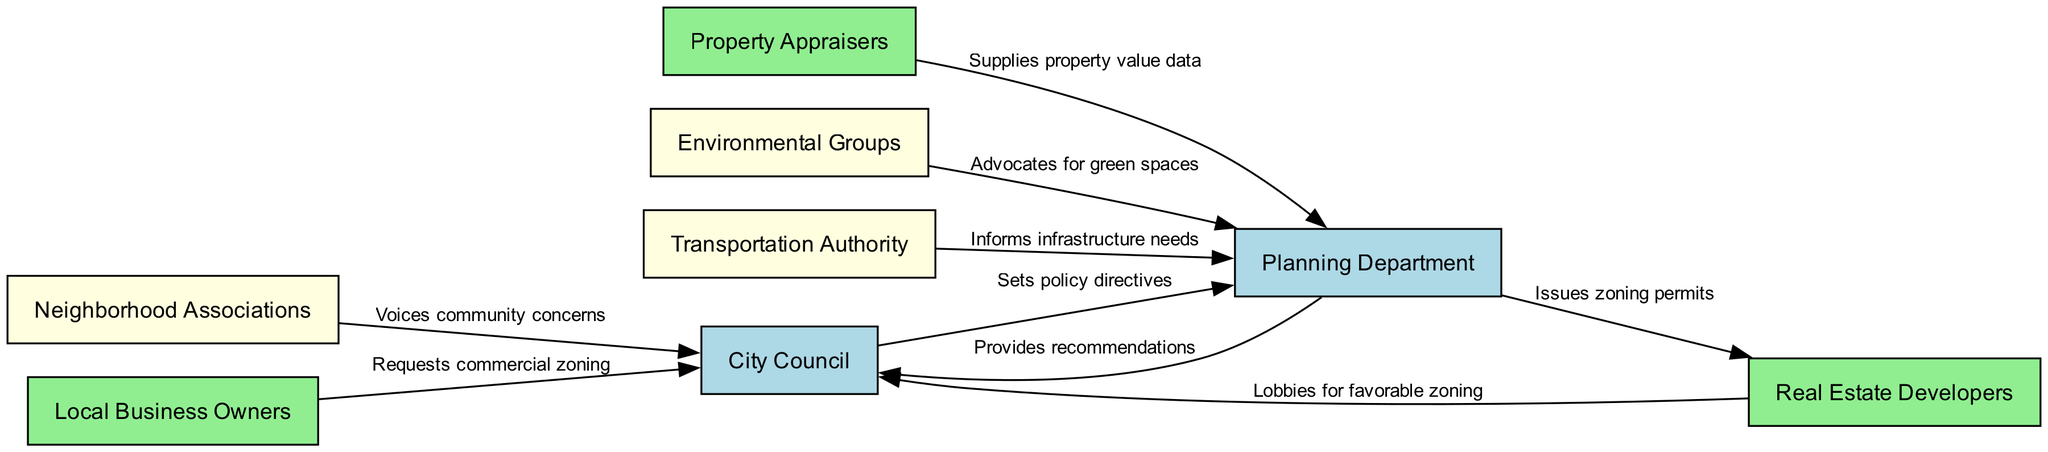What is the total number of nodes in the diagram? The diagram contains a list of entities involved in urban planning decisions, which are represented as nodes. Counting these, we have eight distinct nodes.
Answer: 8 Which entity voices community concerns? By examining the relationships in the diagram, the arrow leading to the City Council labeled "Voices community concerns" indicates that the Neighborhood Associations express community issues.
Answer: Neighborhood Associations What type of relationship does the Planning Department have with Real Estate Developers? The edge between the Planning Department and Real Estate Developers is labeled "Issues zoning permits," indicating a direct relationship where the Planning Department has the responsibility to grant zoning permits to them.
Answer: Issues zoning permits Who provides recommendations to the City Council? The diagram shows a directed edge from the Planning Department to the City Council with the label "Provides recommendations," indicating that the Planning Department is responsible for offering these recommendations.
Answer: Planning Department What is the role of Environmental Groups in the urban planning process? Environmental Groups have a connection to the Planning Department with the edge labeled "Advocates for green spaces," representing their role as advocates for environmental considerations in urban planning.
Answer: Advocates for green spaces Which group lobbies for favorable zoning? The diagram indicates that the Real Estate Developers lobby for zoning changes, as represented by the edge pointing to the City Council labeled "Lobbies for favorable zoning."
Answer: Real Estate Developers How many edges are there in the diagram? Upon reviewing the connections between the entities in the diagram, we can count six distinct edges that illustrate the influence and information flow among the stakeholders.
Answer: 8 What is the main influence of the Transportation Authority? Analysis of the diagram shows that the Transportation Authority informs infrastructure needs, as indicated by the directed edge to the Planning Department labeled "Informs infrastructure needs."
Answer: Informs infrastructure needs Which two entities have a direct influence on the Planning Department? By observing the edges directed towards the Planning Department, we see both Property Appraisers and Environmental Groups providing input, leading to their shared influence over this department.
Answer: Property Appraisers, Environmental Groups 